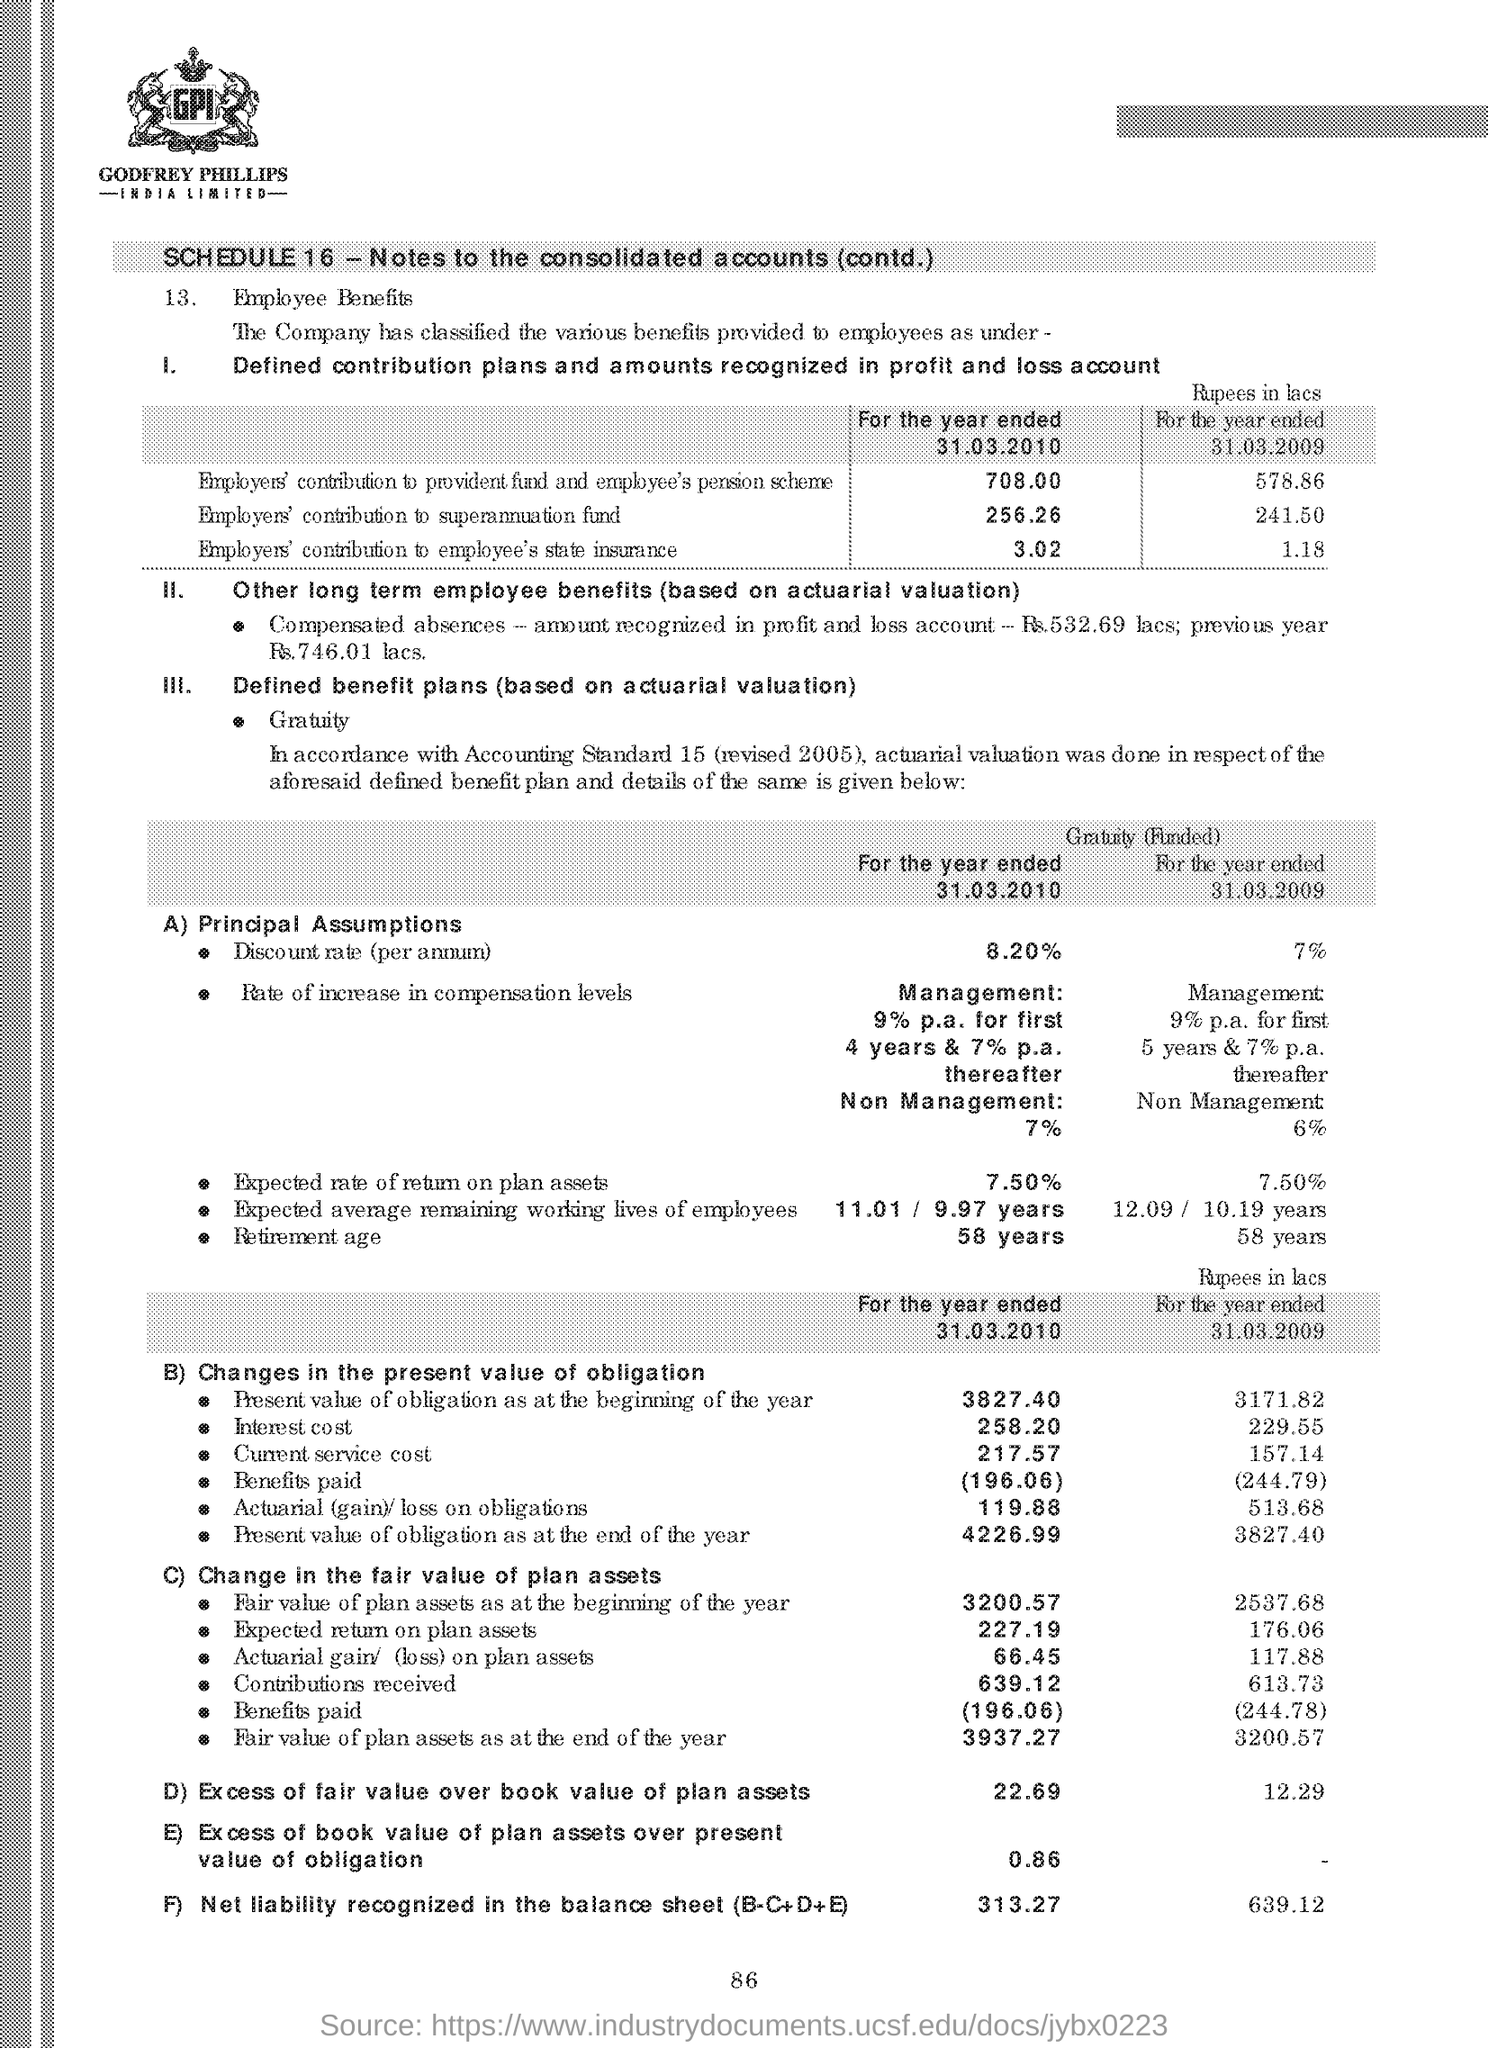What does the point A's heading say?
Offer a terse response. Principal Assumptions. Which number of schedule is mentioned in the first line of the document?
Offer a very short reply. Schedule 16. 